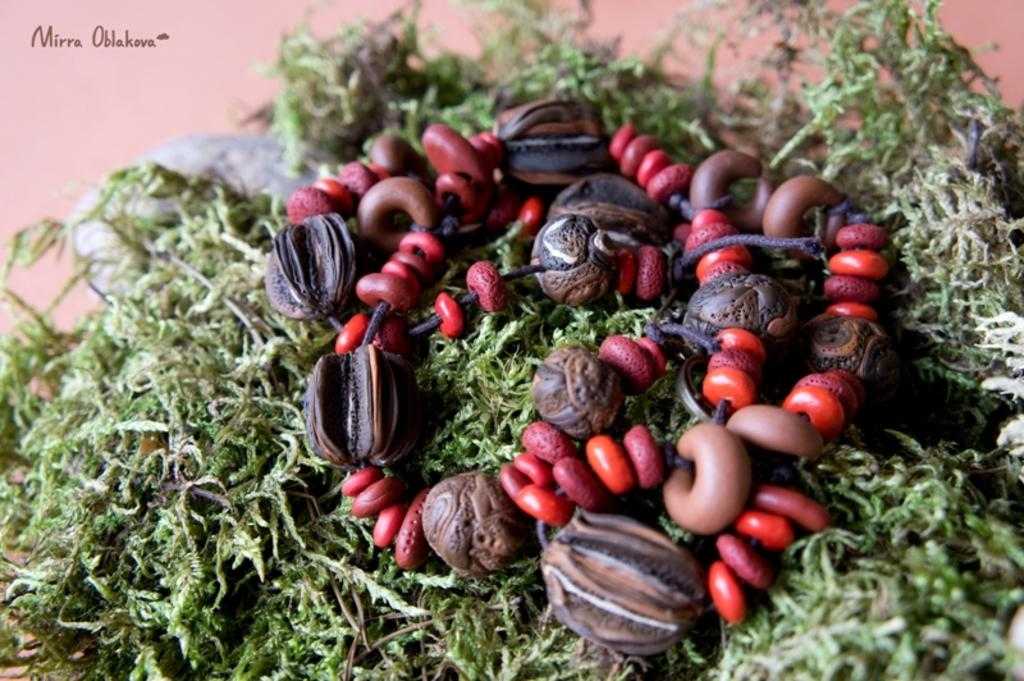What type of natural elements can be seen in the image? There are leaves in the image. What object is located in the middle of the image? There is a necklace in the middle of the image. Where is the text positioned in the image? The text is in the top left of the image. How many thumbs are visible in the image? There are no thumbs present in the image. What type of approval is being given in the image? There is no indication of approval or any related action in the image. 